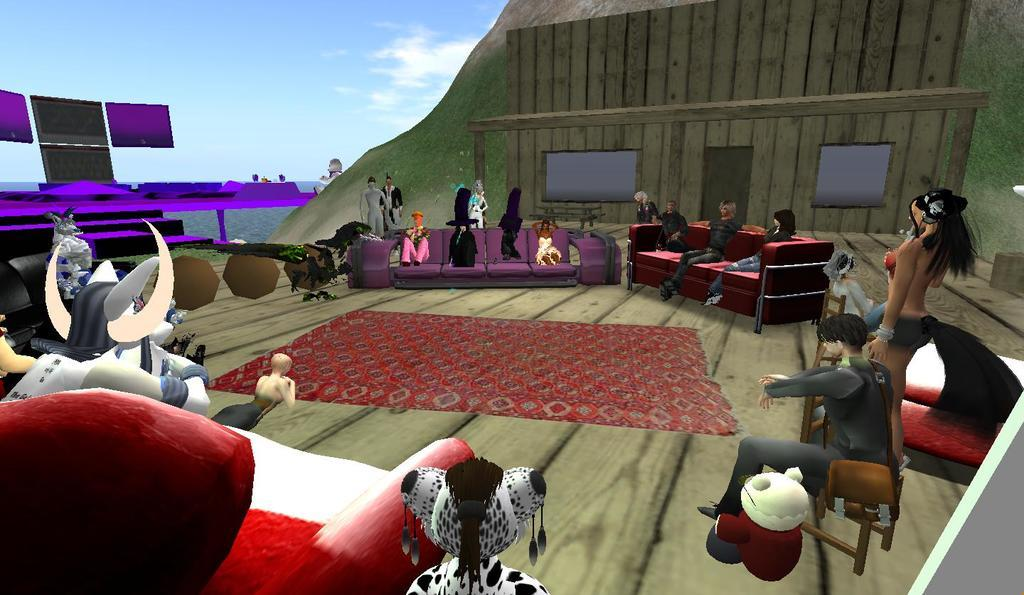What type of games are featured in the image? The image contains PC games. Can you describe the setting of the image? The people and animals are on a ship, and there is water visible in the background. How many groups of living beings can be seen in the image? There are two groups of living beings in the image: people and animals. What is the aftermath of the roll in the image? There is no roll or any related aftermath in the image. The image features people and animals on a ship with PC games, but there is no indication of any rolling or related events. 